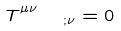Convert formula to latex. <formula><loc_0><loc_0><loc_500><loc_500>T ^ { \mu \nu } _ { \quad ; \nu } = 0</formula> 